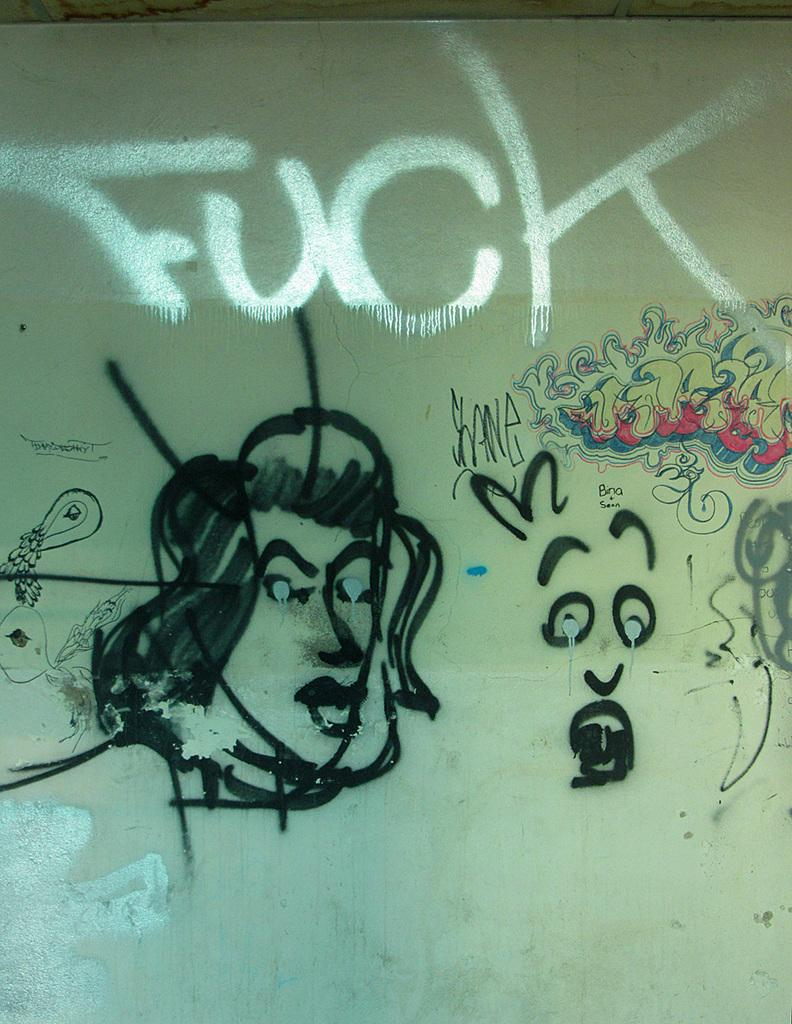What is depicted on the wall in the image? There is a painting on a wall in the image. How many people are taking a bath in the image? A: There are no people taking a bath in the image, as the only subject mentioned is a painting on a wall. 